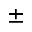Convert formula to latex. <formula><loc_0><loc_0><loc_500><loc_500>\pm</formula> 